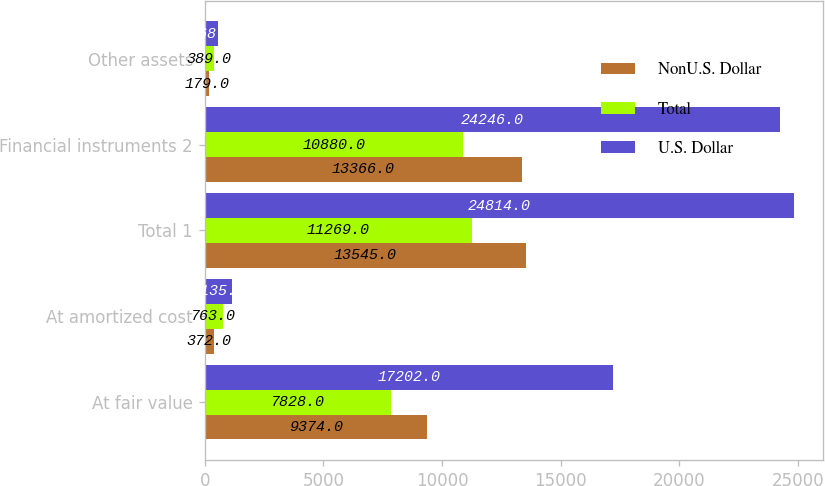<chart> <loc_0><loc_0><loc_500><loc_500><stacked_bar_chart><ecel><fcel>At fair value<fcel>At amortized cost<fcel>Total 1<fcel>Financial instruments 2<fcel>Other assets<nl><fcel>NonU.S. Dollar<fcel>9374<fcel>372<fcel>13545<fcel>13366<fcel>179<nl><fcel>Total<fcel>7828<fcel>763<fcel>11269<fcel>10880<fcel>389<nl><fcel>U.S. Dollar<fcel>17202<fcel>1135<fcel>24814<fcel>24246<fcel>568<nl></chart> 